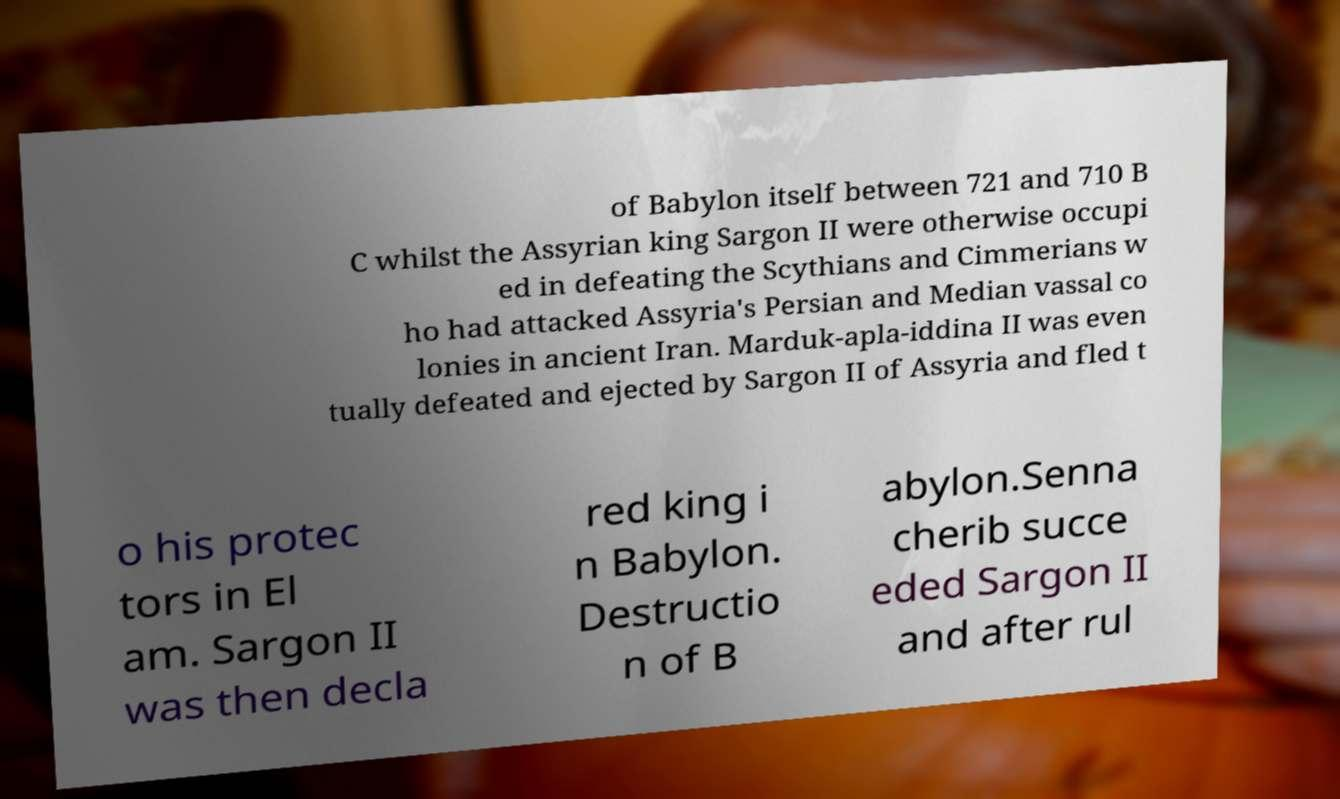There's text embedded in this image that I need extracted. Can you transcribe it verbatim? of Babylon itself between 721 and 710 B C whilst the Assyrian king Sargon II were otherwise occupi ed in defeating the Scythians and Cimmerians w ho had attacked Assyria's Persian and Median vassal co lonies in ancient Iran. Marduk-apla-iddina II was even tually defeated and ejected by Sargon II of Assyria and fled t o his protec tors in El am. Sargon II was then decla red king i n Babylon. Destructio n of B abylon.Senna cherib succe eded Sargon II and after rul 